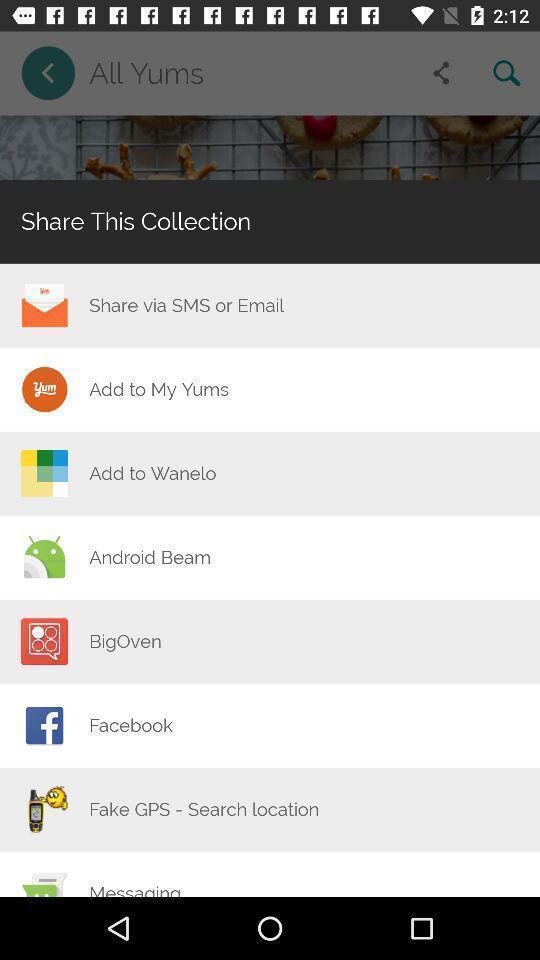Describe the key features of this screenshot. Share list of collections of all yums. 